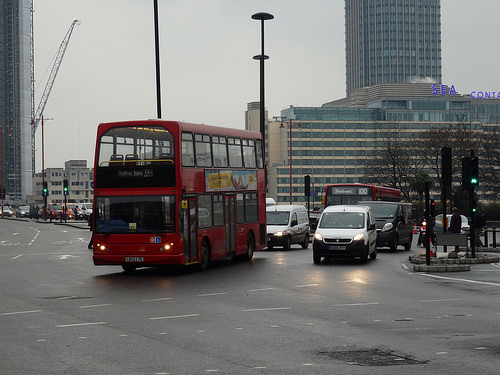<image>
Is there a bus next to the car? Yes. The bus is positioned adjacent to the car, located nearby in the same general area. 